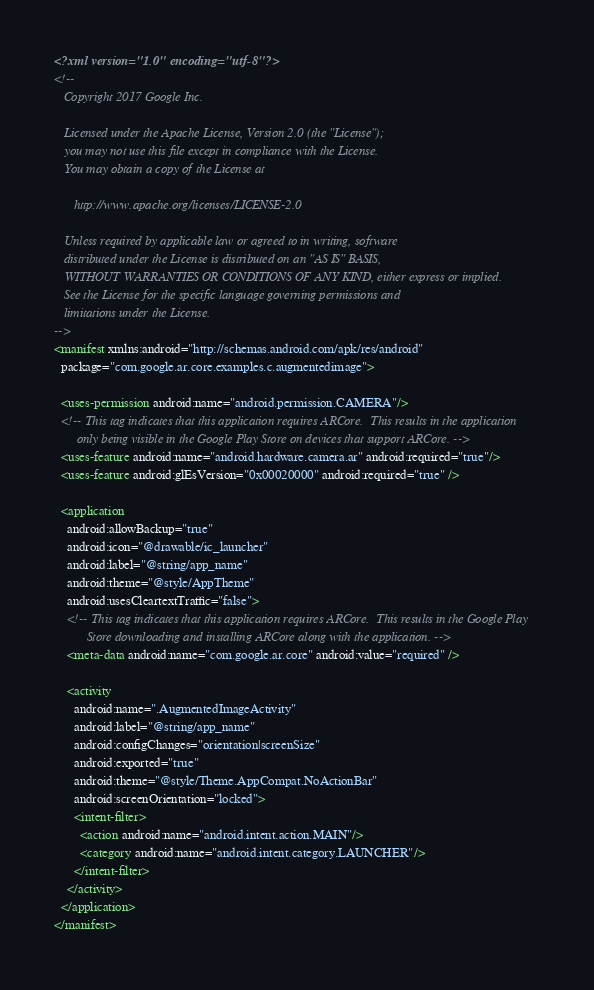Convert code to text. <code><loc_0><loc_0><loc_500><loc_500><_XML_><?xml version="1.0" encoding="utf-8"?>
<!--
   Copyright 2017 Google Inc.

   Licensed under the Apache License, Version 2.0 (the "License");
   you may not use this file except in compliance with the License.
   You may obtain a copy of the License at

      http://www.apache.org/licenses/LICENSE-2.0

   Unless required by applicable law or agreed to in writing, software
   distributed under the License is distributed on an "AS IS" BASIS,
   WITHOUT WARRANTIES OR CONDITIONS OF ANY KIND, either express or implied.
   See the License for the specific language governing permissions and
   limitations under the License.
-->
<manifest xmlns:android="http://schemas.android.com/apk/res/android"
  package="com.google.ar.core.examples.c.augmentedimage">

  <uses-permission android:name="android.permission.CAMERA"/>
  <!-- This tag indicates that this application requires ARCore.  This results in the application
       only being visible in the Google Play Store on devices that support ARCore. -->
  <uses-feature android:name="android.hardware.camera.ar" android:required="true"/>
  <uses-feature android:glEsVersion="0x00020000" android:required="true" />

  <application
    android:allowBackup="true"
    android:icon="@drawable/ic_launcher"
    android:label="@string/app_name"
    android:theme="@style/AppTheme"
    android:usesCleartextTraffic="false">
    <!-- This tag indicates that this application requires ARCore.  This results in the Google Play
          Store downloading and installing ARCore along with the application. -->
    <meta-data android:name="com.google.ar.core" android:value="required" />

    <activity
      android:name=".AugmentedImageActivity"
      android:label="@string/app_name"
      android:configChanges="orientation|screenSize"
      android:exported="true"
      android:theme="@style/Theme.AppCompat.NoActionBar"
      android:screenOrientation="locked">
      <intent-filter>
        <action android:name="android.intent.action.MAIN"/>
        <category android:name="android.intent.category.LAUNCHER"/>
      </intent-filter>
    </activity>
  </application>
</manifest>
</code> 